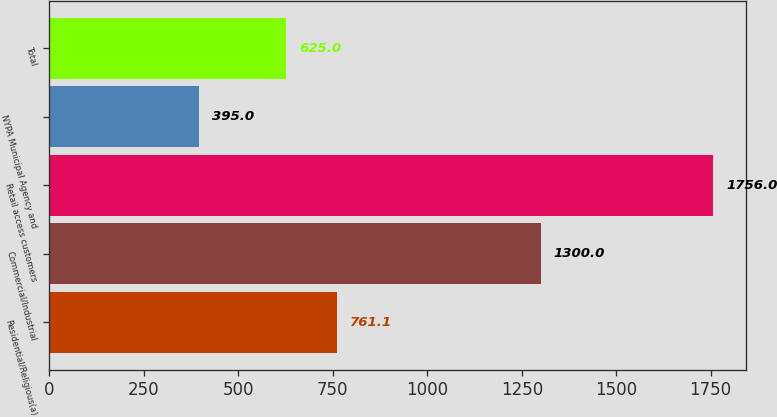Convert chart to OTSL. <chart><loc_0><loc_0><loc_500><loc_500><bar_chart><fcel>Residential/Religious(a)<fcel>Commercial/Industrial<fcel>Retail access customers<fcel>NYPA Municipal Agency and<fcel>Total<nl><fcel>761.1<fcel>1300<fcel>1756<fcel>395<fcel>625<nl></chart> 